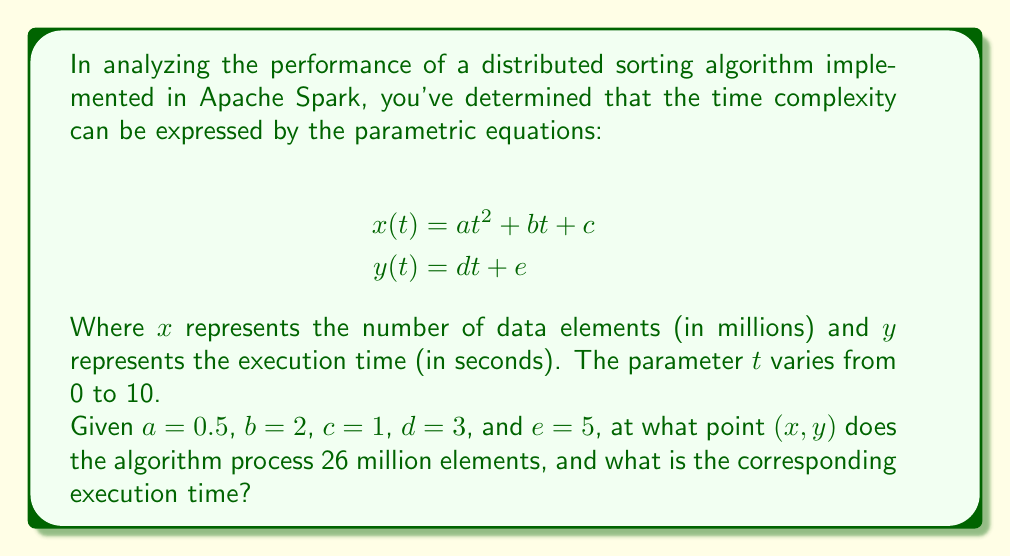Can you solve this math problem? To solve this problem, we need to follow these steps:

1) We're looking for the point where $x = 26$ million elements. So we need to solve the equation:

   $$26 = 0.5t^2 + 2t + 1$$

2) This is a quadratic equation. Let's rearrange it into standard form:

   $$0.5t^2 + 2t - 25 = 0$$

3) We can solve this using the quadratic formula: $t = \frac{-b \pm \sqrt{b^2 - 4ac}}{2a}$

   Where $a = 0.5$, $b = 2$, and $c = -25$

4) Plugging these values into the quadratic formula:

   $$t = \frac{-2 \pm \sqrt{2^2 - 4(0.5)(-25)}}{2(0.5)}$$
   
   $$= \frac{-2 \pm \sqrt{4 + 50}}{1} = \frac{-2 \pm \sqrt{54}}{1}$$

5) Simplifying:

   $$t = -2 \pm \sqrt{54} \approx -2 \pm 7.35$$

6) This gives us two solutions: $t \approx 5.35$ or $t \approx -9.35$. Since time can't be negative in this context, we use $t \approx 5.35$.

7) Now that we know $t$, we can find $y$ using the second parametric equation:

   $$y = 3t + 5$$
   $$y = 3(5.35) + 5 \approx 21.05$$

Therefore, the point $(x, y)$ where the algorithm processes 26 million elements is approximately $(26, 21.05)$.
Answer: The algorithm processes 26 million elements at the point $(26, 21.05)$, with an execution time of approximately 21.05 seconds. 